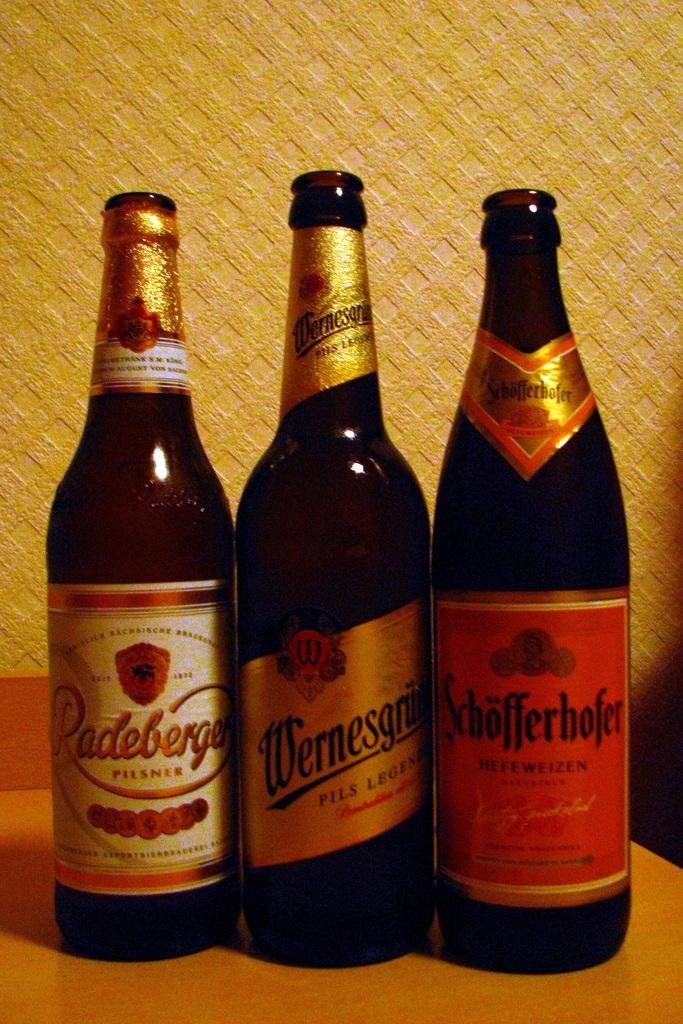<image>
Summarize the visual content of the image. Three bottles of alcohol with differently colored labels one being Schofferhoffer are standing next to each other. 